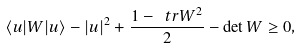<formula> <loc_0><loc_0><loc_500><loc_500>\langle u | W | u \rangle - | u | ^ { 2 } + \frac { 1 - \ t r W ^ { 2 } } { 2 } - \det { W } \geq 0 ,</formula> 